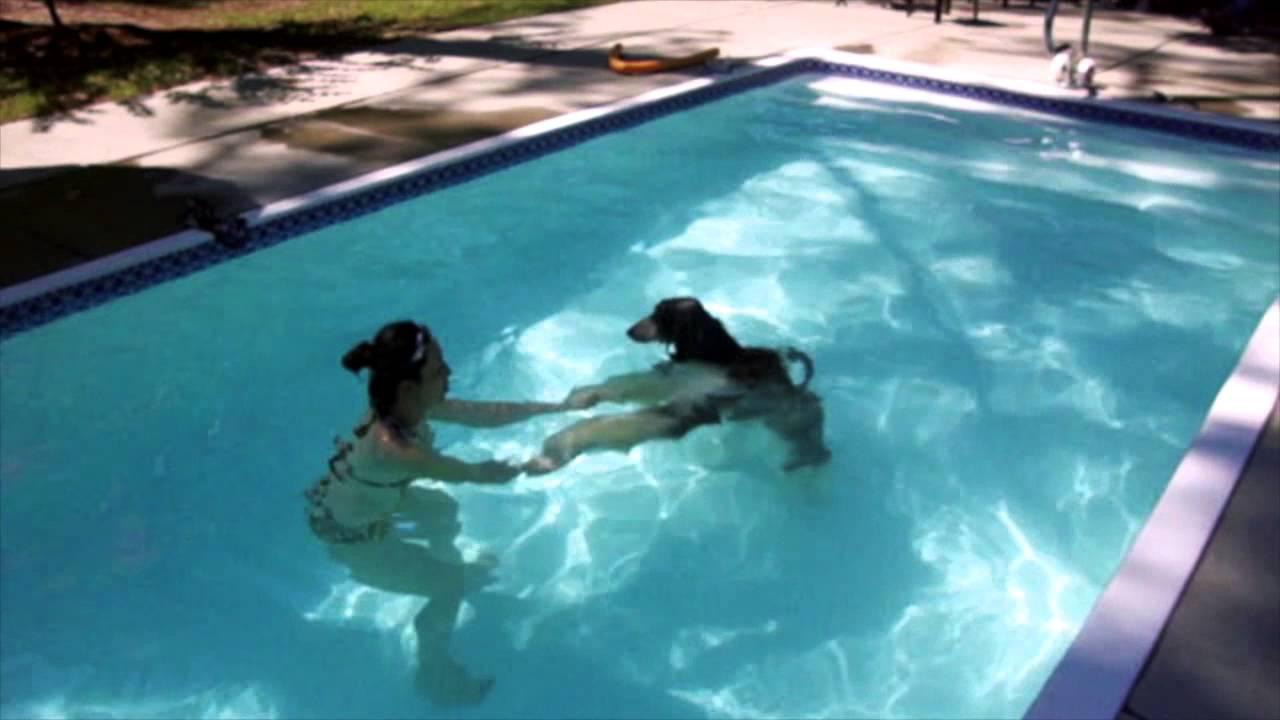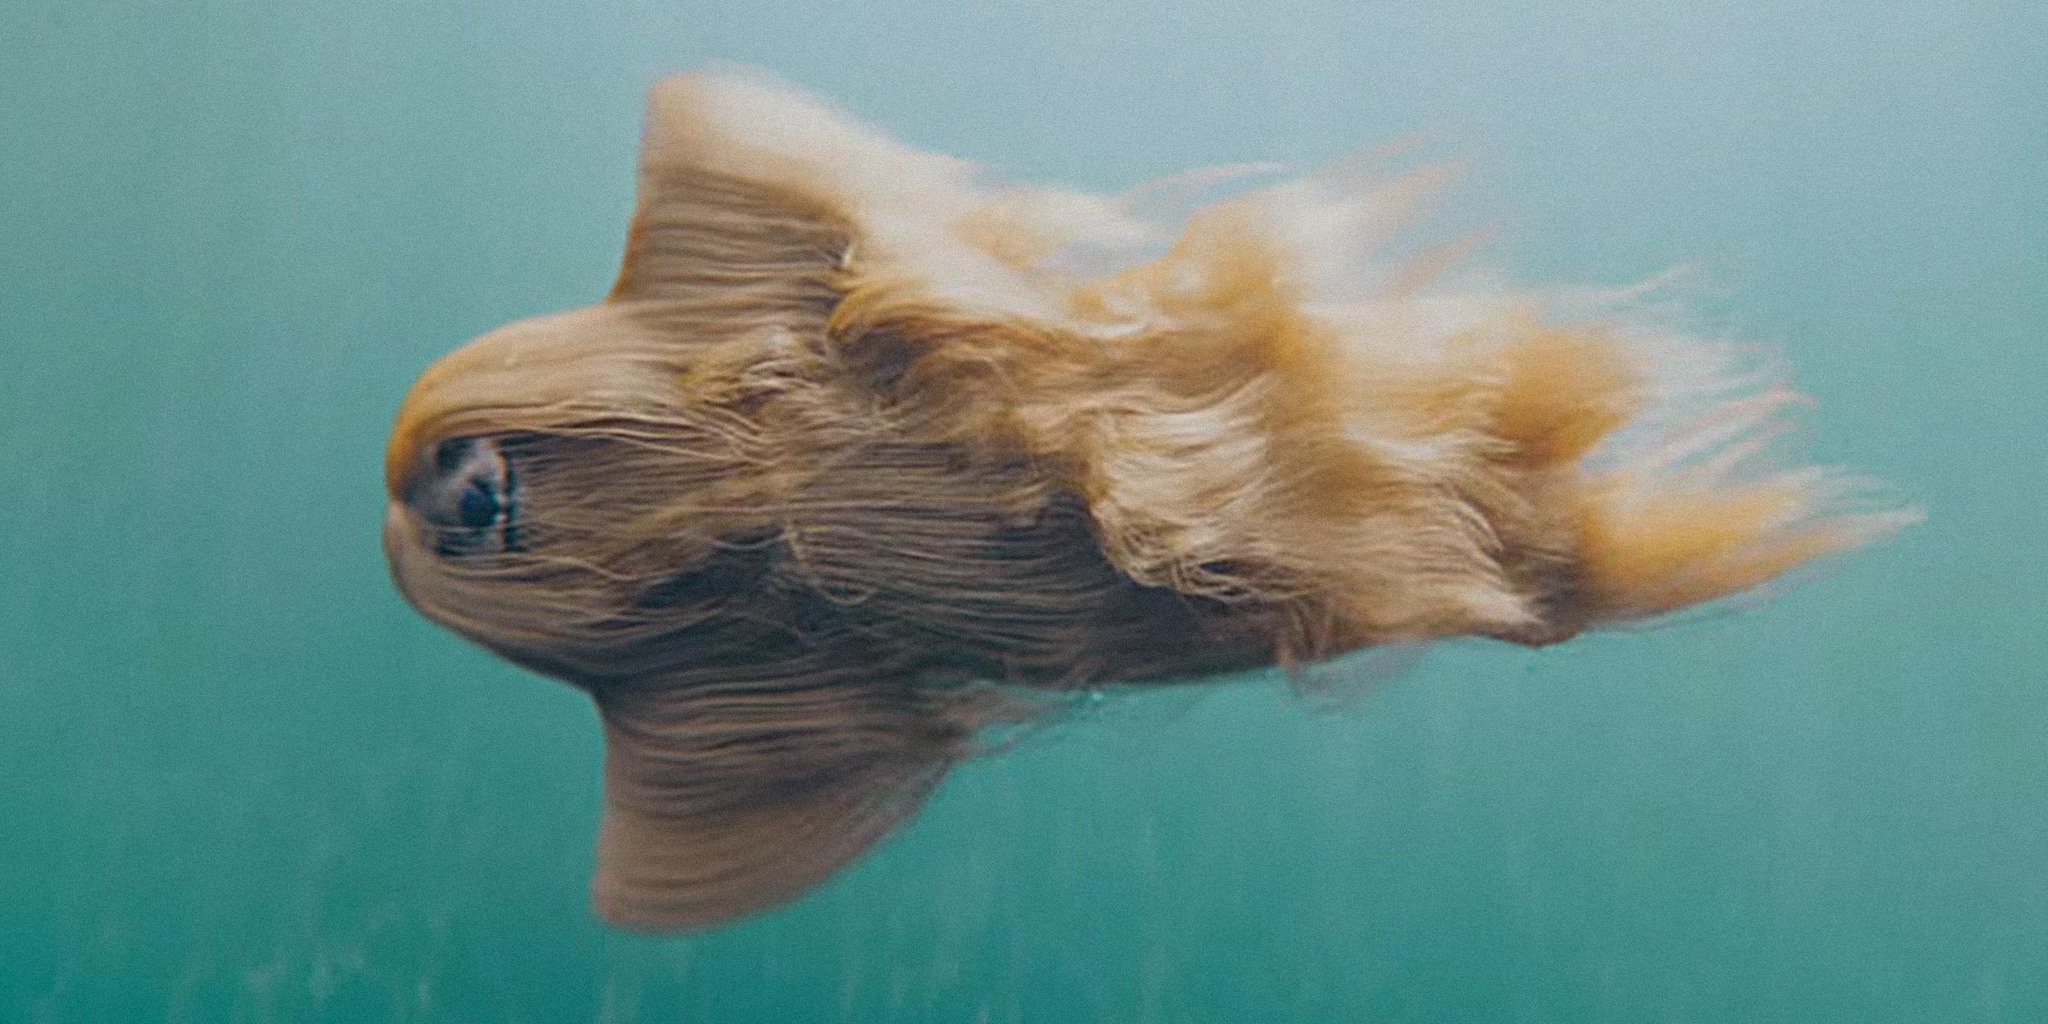The first image is the image on the left, the second image is the image on the right. Assess this claim about the two images: "A dog is completely submerged in the water.". Correct or not? Answer yes or no. Yes. The first image is the image on the left, the second image is the image on the right. For the images shown, is this caption "One image shows a dog underwater and sideways, with its head to the left and its long fur trailing rightward." true? Answer yes or no. Yes. 